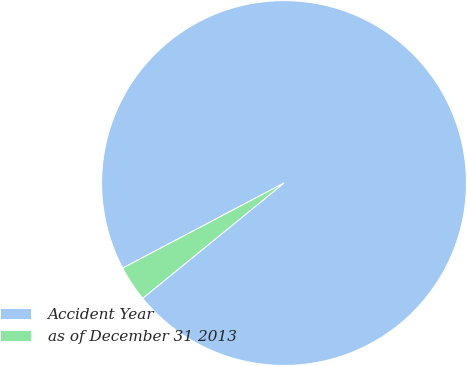Convert chart. <chart><loc_0><loc_0><loc_500><loc_500><pie_chart><fcel>Accident Year<fcel>as of December 31 2013<nl><fcel>96.84%<fcel>3.16%<nl></chart> 